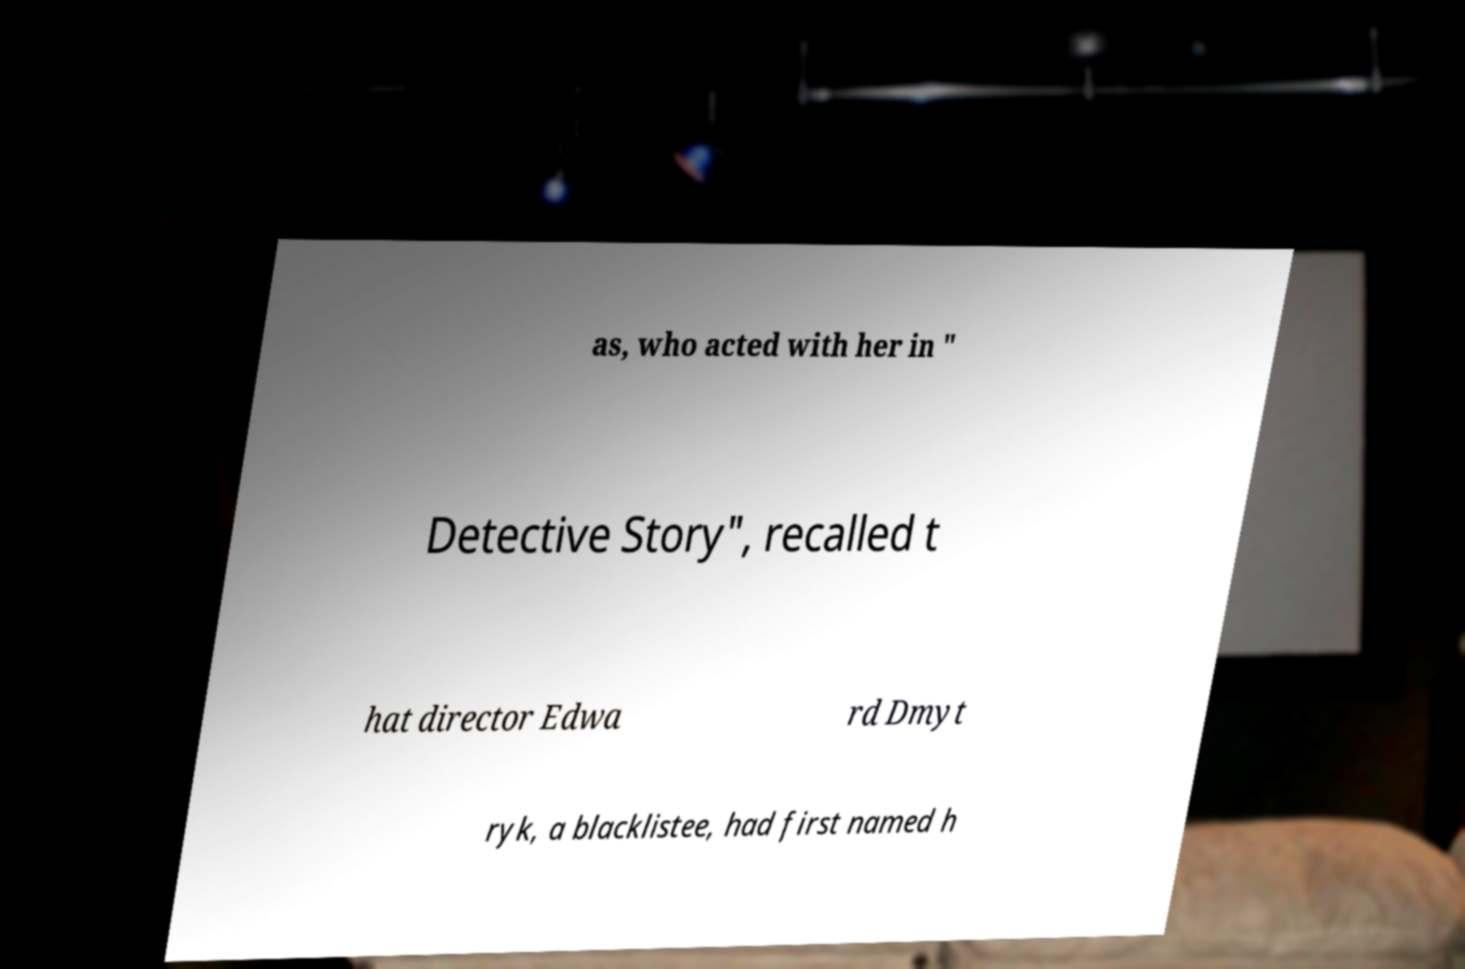Could you extract and type out the text from this image? as, who acted with her in " Detective Story", recalled t hat director Edwa rd Dmyt ryk, a blacklistee, had first named h 